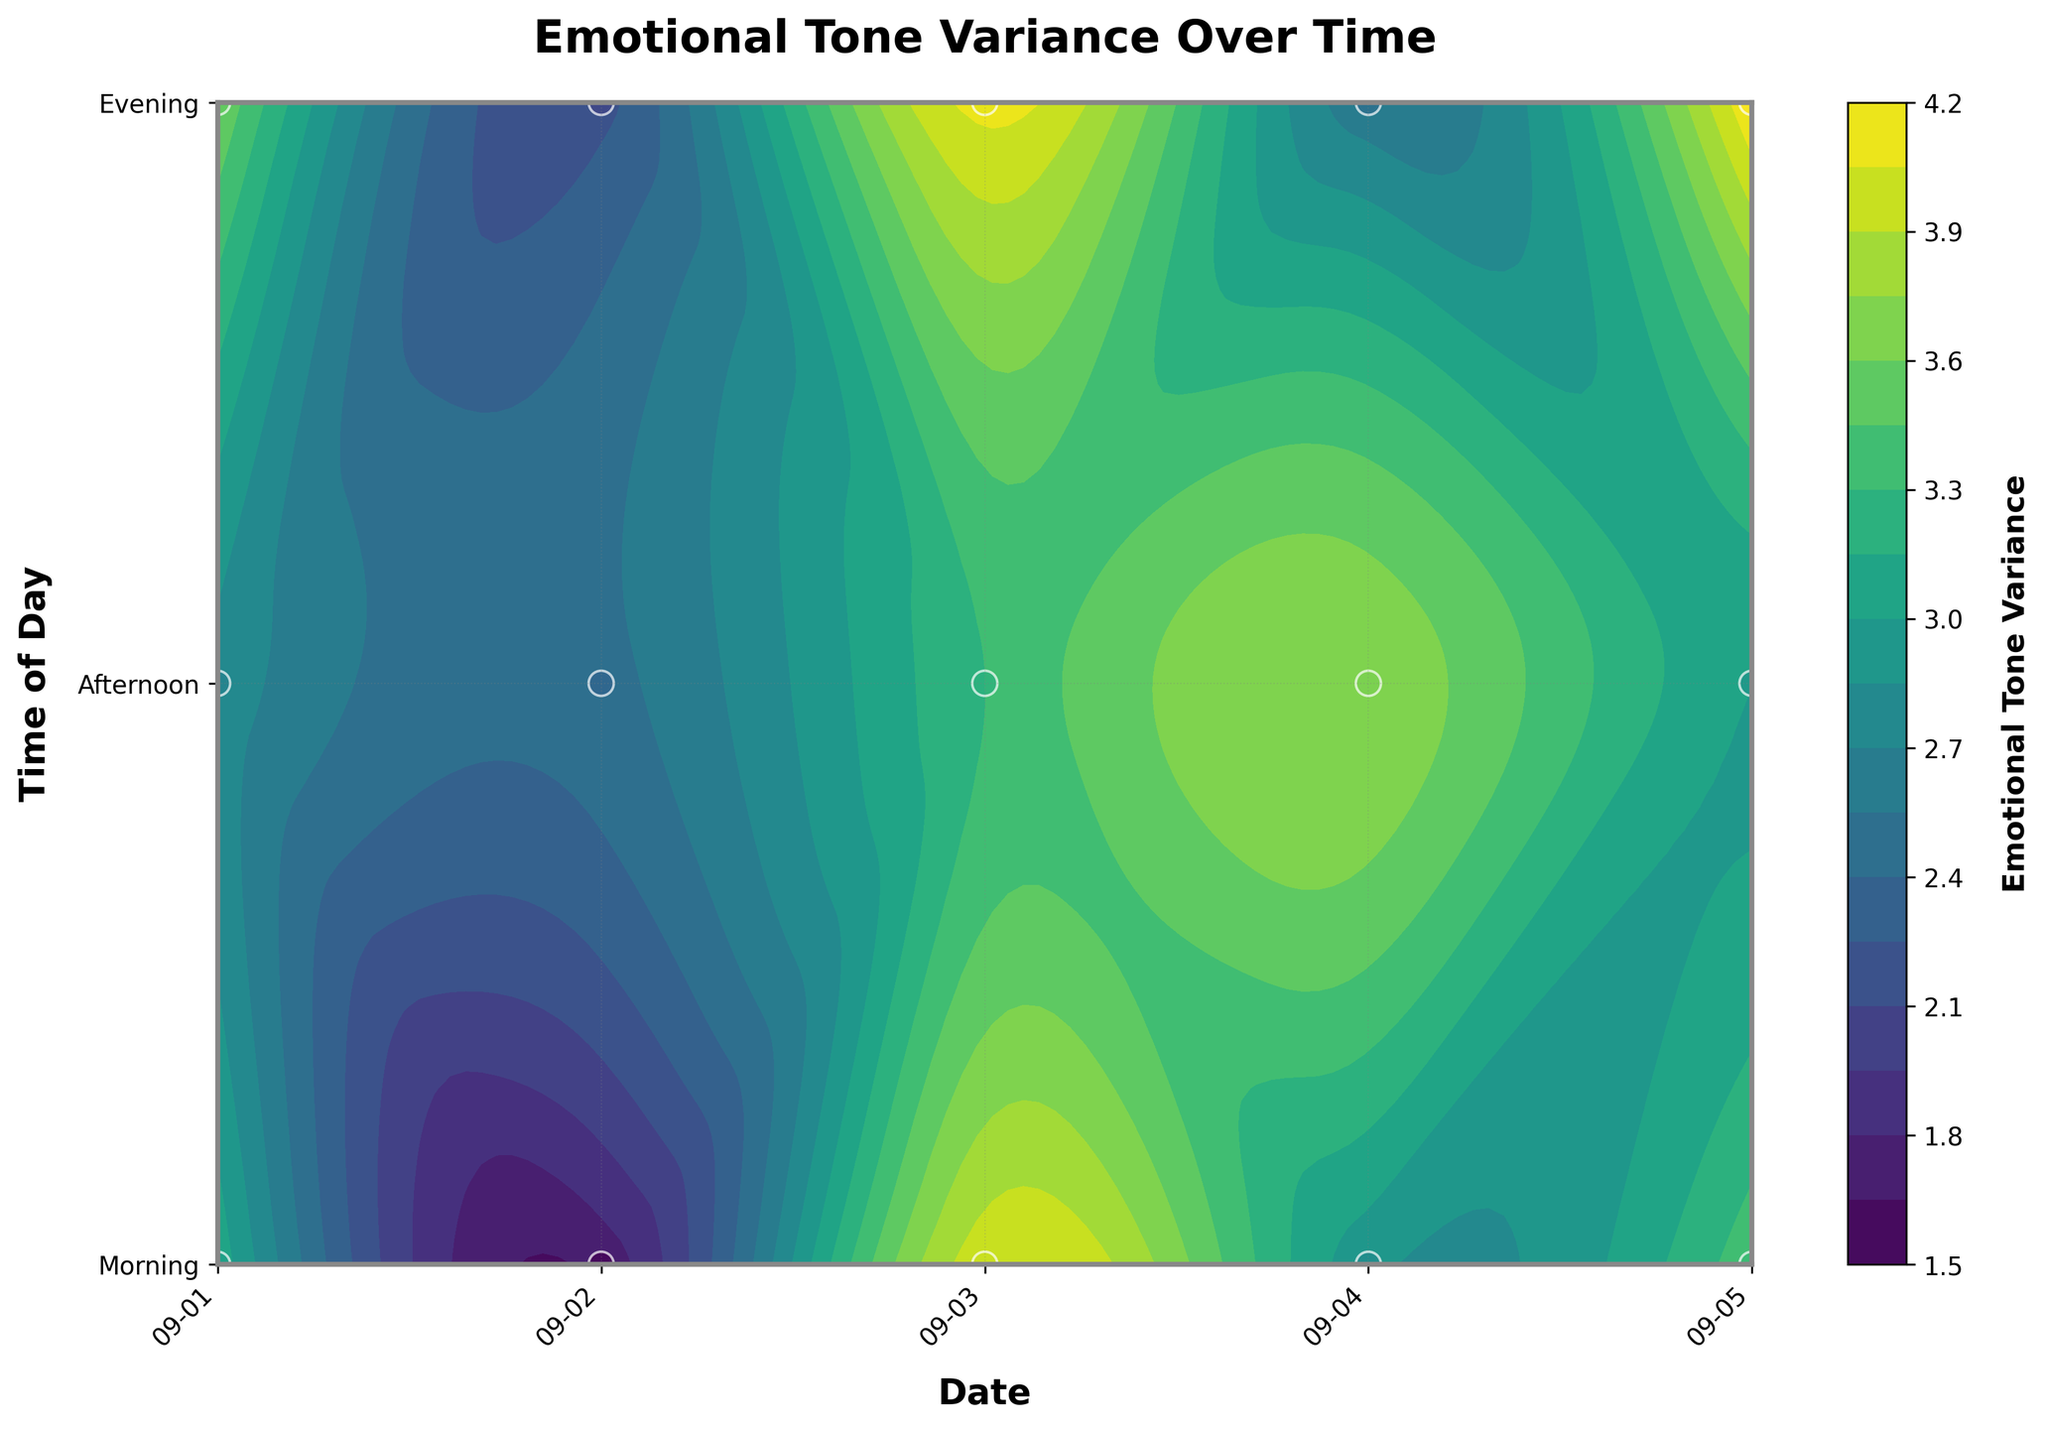What's the title of the plot? The plot's title is typically displayed prominently at the top and usually summarizes the data presented in the visualization. Here, it reads "Emotional Tone Variance Over Time."
Answer: Emotional Tone Variance Over Time What are the labels on the y-axis? The y-axis labels are visible running vertically along the left side and typically indicate the variable being measured. In this case, the labels are "Morning," "Afternoon," and "Evening."
Answer: Morning, Afternoon, Evening Which date has the highest emotional tone variance? To answer this, observe the color intensity (usually darker or brighter colors indicate higher values) on the date axis. September 5th, particularly during the "Evening," seems to have the highest variance.
Answer: September 5 How did the emotional tone variance change from morning to evening on September 2nd? By following the contour lines or color changes along September 2, you can see that the variance starts relatively low in the morning, increases slightly in the afternoon, and then decreases again in the evening.
Answer: Increased then decreased On which day did the afternoon emotional tone variance peak? Look for the highest color intensity in the "Afternoon" time slot across all days and check the corresponding date. The peak happens on September 4th in the afternoon.
Answer: September 4 Compare the emotional tone variance between September 3rd and September 1st during the evening. Which one is higher? Examining the contours for both dates in the "Evening" time slot, September 3rd has a higher variance compared to September 1st.
Answer: September 3 What is the overall trend in emotional tone variance over the five days? Observing the entire plot, the emotional tone variance seems to fluctuate without a clear, consistent upward or downward trend. It varies with no distinct pattern across different times of the day.
Answer: Fluctuating What does the color bar represent in this plot? The color bar, usually positioned beside the main plot, indicates the range of values for the plotted variable. Here, it represents the emotional tone variance, with different colors corresponding to different variance levels.
Answer: Emotional tone variance What is the variance in emotional tone for the morning of September 1st? By finding the relevant spot on the plot and checking the color or contour level, the emotional tone variance for the morning of September 1st is 3.1.
Answer: 3.1 Which time of the day shows the most consistent emotional tone variance over the observed period? By scanning the plot, particularly the y-axis sections, and evaluating how much the color varies, the "Afternoon" time slot generally appears to have less variation in color compared to "Morning" and "Evening."
Answer: Afternoon 